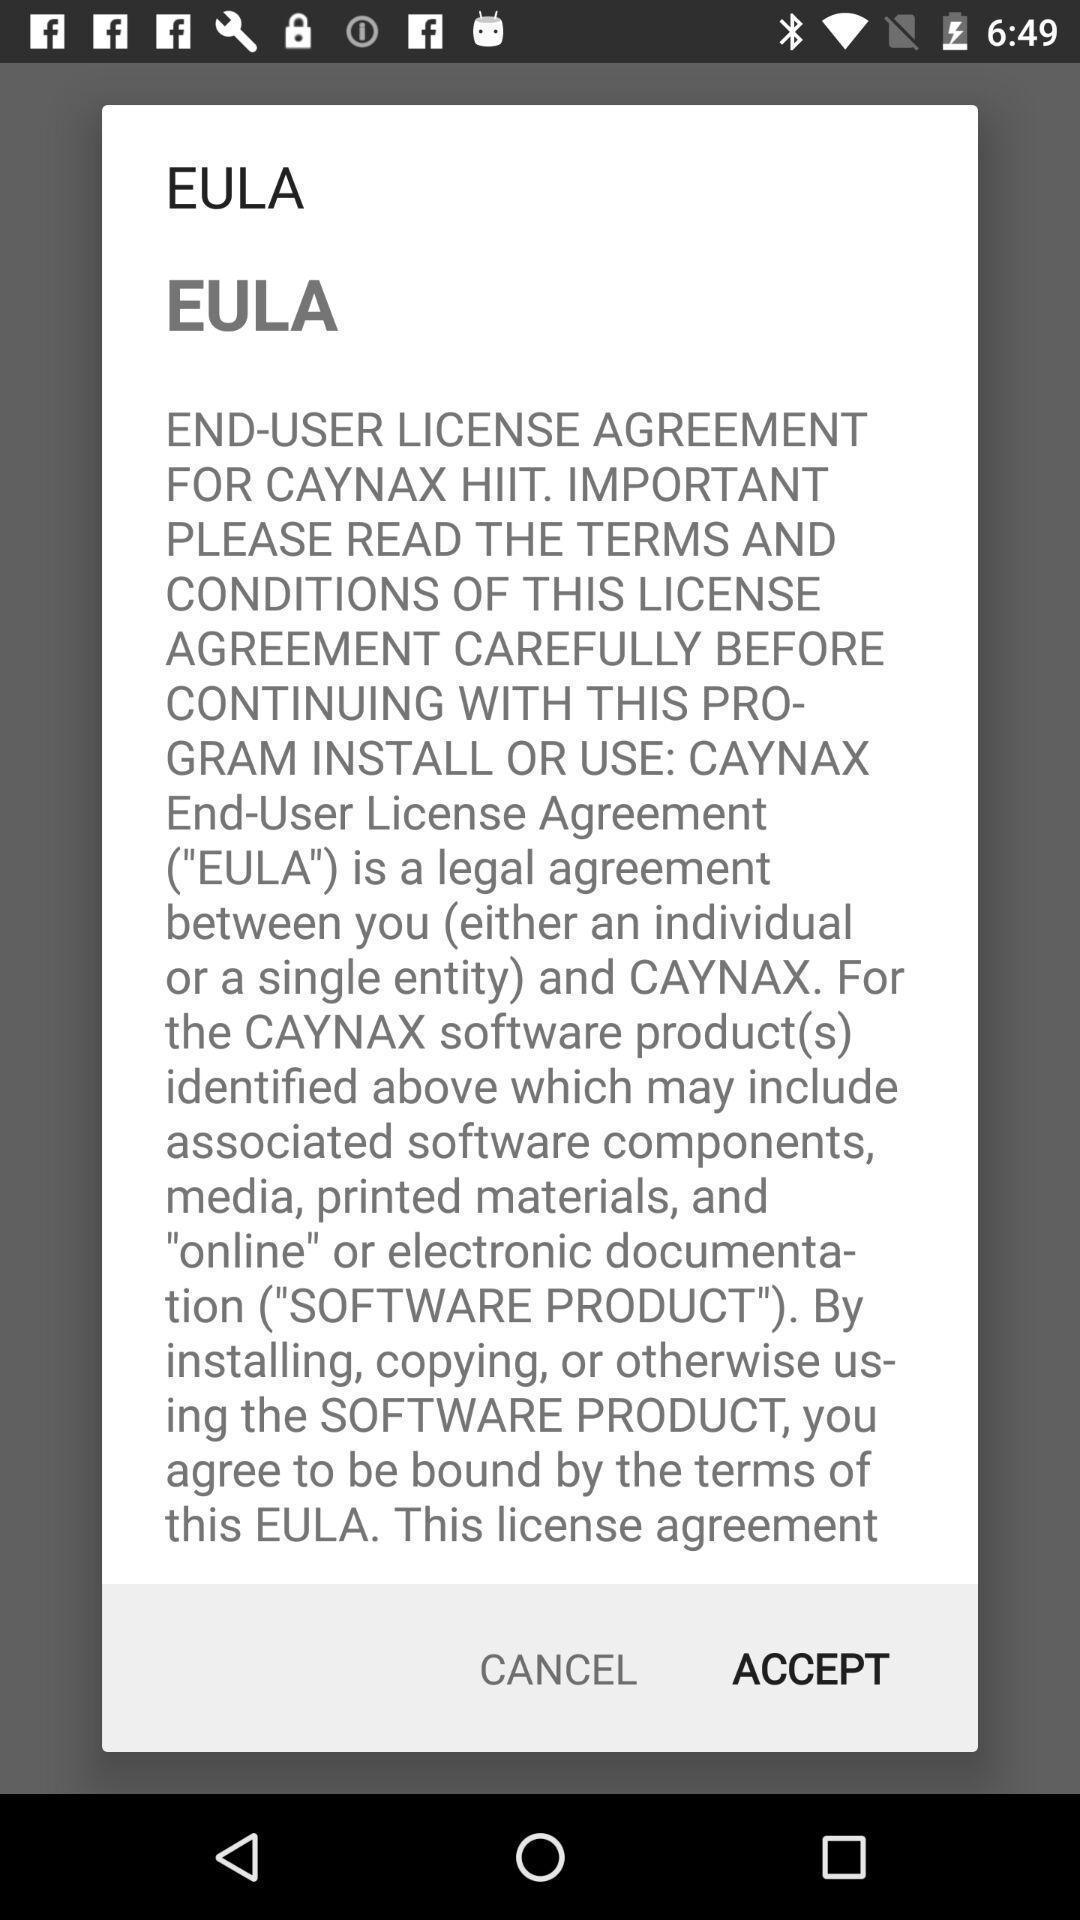Describe this image in words. Pop-up to accept or decline of license agreement. 